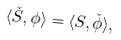Convert formula to latex. <formula><loc_0><loc_0><loc_500><loc_500>\langle \check { S } , \phi \rangle = \langle S , \check { \phi } \rangle ,</formula> 